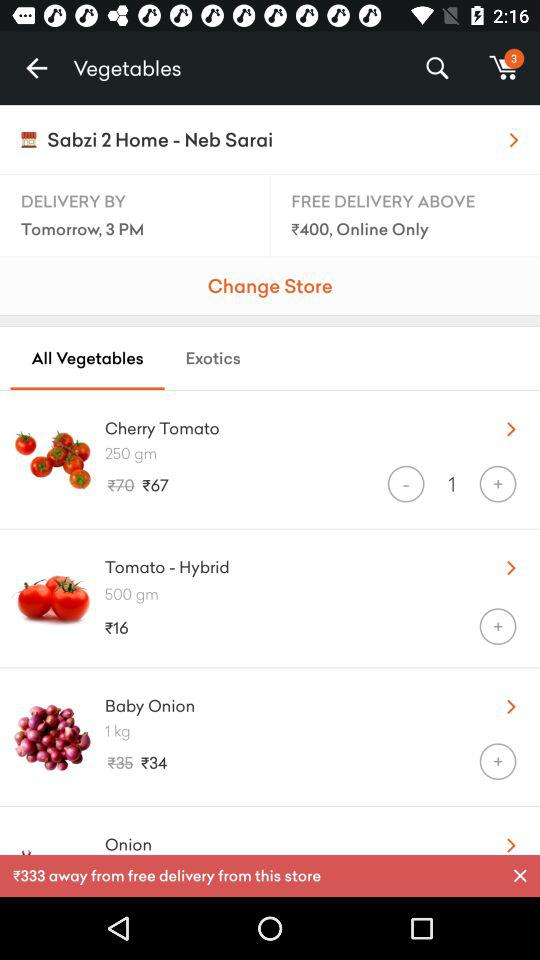What is the delivery address?
When the provided information is insufficient, respond with <no answer>. <no answer> 